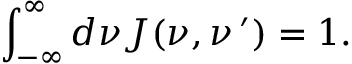<formula> <loc_0><loc_0><loc_500><loc_500>\int _ { - \infty } ^ { \infty } d \nu J ( \nu , \nu \, ^ { \prime } ) = 1 .</formula> 